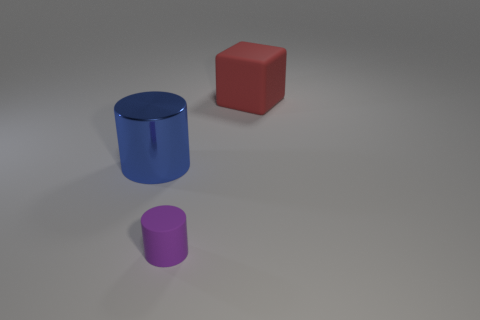Add 3 red things. How many objects exist? 6 Subtract all cubes. How many objects are left? 2 Add 2 tiny brown matte things. How many tiny brown matte things exist? 2 Subtract 0 red spheres. How many objects are left? 3 Subtract all large green cubes. Subtract all large rubber cubes. How many objects are left? 2 Add 3 rubber cylinders. How many rubber cylinders are left? 4 